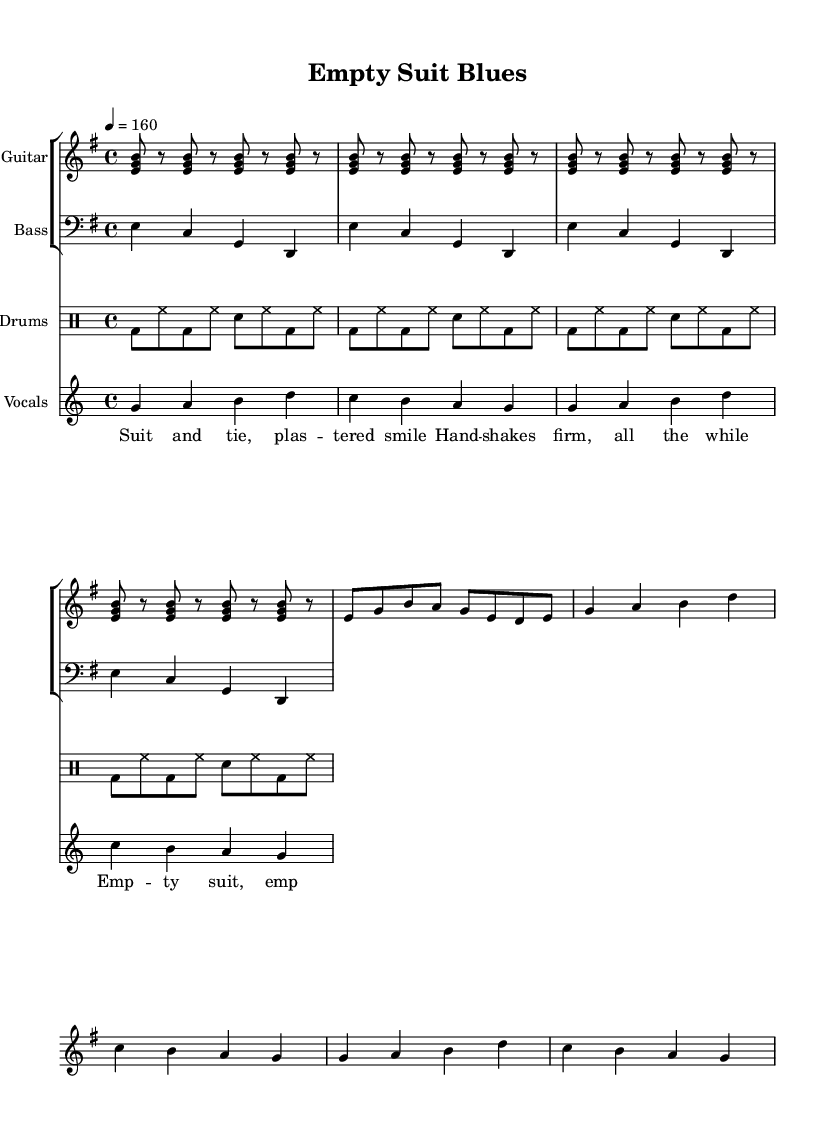What is the key signature of this music? The key signature is E minor, which has one sharp (F#). This can be identified from the key signature notation at the beginning of the score.
Answer: E minor What is the time signature of this music? The time signature is 4/4, indicated at the beginning of the score. This means there are four beats in each measure and the quarter note gets one beat.
Answer: 4/4 What is the tempo marking for this piece? The tempo marking is quarter note equals 160, which is indicated at the beginning of the score. This indicates how fast the music should be played.
Answer: 160 How many measures does the vocal melody last for? The vocal melody occurs over 4 measures, as evidenced by the repeat indication (each cycle of the lyrics corresponds with a musical measure).
Answer: 4 Which instrument has the part labeled "Guitar"? The part labeled "Guitar" is for the first staff in the score, specifically shown by the instrument name above that staff.
Answer: Guitar What phrase is repeated in the chorus? The phrase "emp - ty suit, emp - ty words" is stated multiple times, highlighted in the lyrics section under the chorus label.
Answer: empty suit, empty words What type of song is represented in this sheet music? The song is a satirical punk song, as indicated by its title "Empty Suit Blues," which suggests a critique of politicians and their empty promises, a common theme in punk music.
Answer: satirical punk 